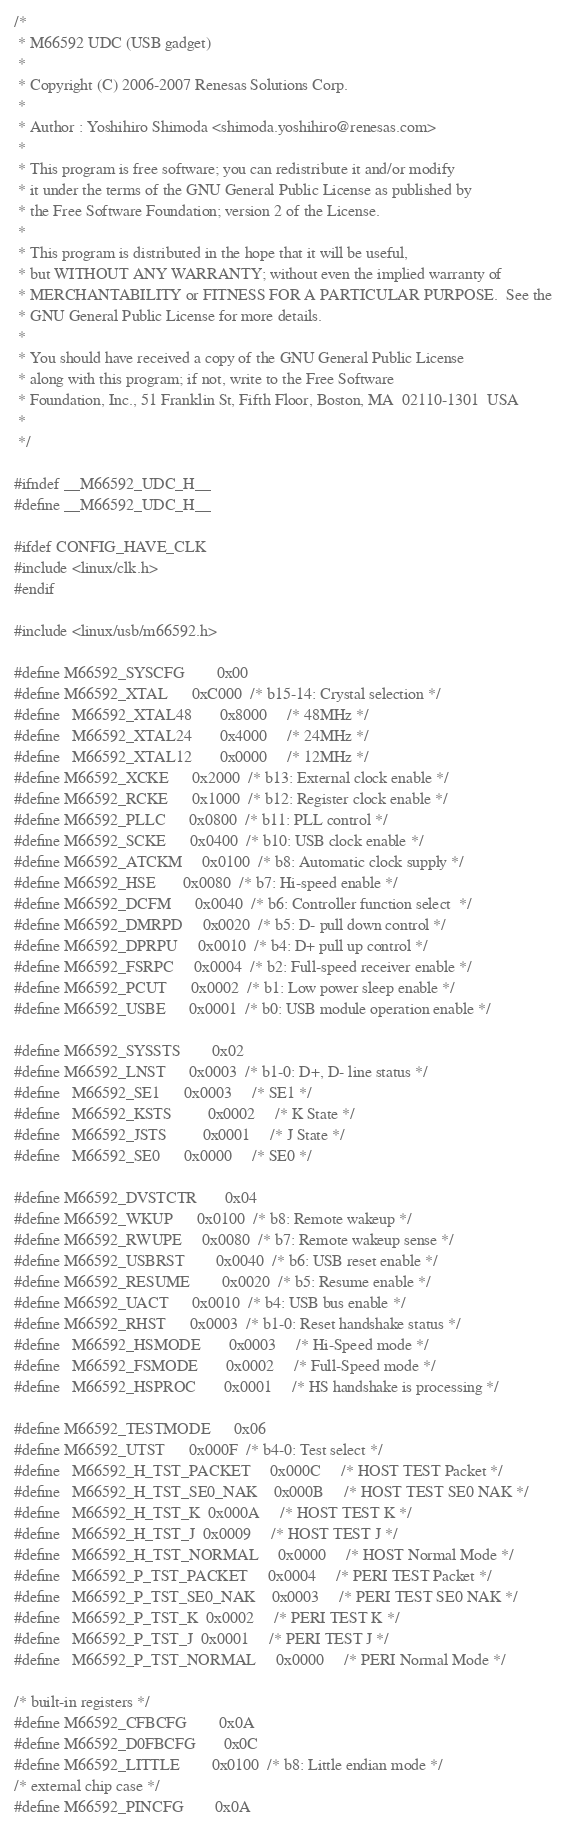Convert code to text. <code><loc_0><loc_0><loc_500><loc_500><_C_>/*
 * M66592 UDC (USB gadget)
 *
 * Copyright (C) 2006-2007 Renesas Solutions Corp.
 *
 * Author : Yoshihiro Shimoda <shimoda.yoshihiro@renesas.com>
 *
 * This program is free software; you can redistribute it and/or modify
 * it under the terms of the GNU General Public License as published by
 * the Free Software Foundation; version 2 of the License.
 *
 * This program is distributed in the hope that it will be useful,
 * but WITHOUT ANY WARRANTY; without even the implied warranty of
 * MERCHANTABILITY or FITNESS FOR A PARTICULAR PURPOSE.  See the
 * GNU General Public License for more details.
 *
 * You should have received a copy of the GNU General Public License
 * along with this program; if not, write to the Free Software
 * Foundation, Inc., 51 Franklin St, Fifth Floor, Boston, MA  02110-1301  USA
 *
 */

#ifndef __M66592_UDC_H__
#define __M66592_UDC_H__

#ifdef CONFIG_HAVE_CLK
#include <linux/clk.h>
#endif

#include <linux/usb/m66592.h>

#define M66592_SYSCFG		0x00
#define M66592_XTAL		0xC000	/* b15-14: Crystal selection */
#define   M66592_XTAL48		 0x8000		/* 48MHz */
#define   M66592_XTAL24		 0x4000		/* 24MHz */
#define   M66592_XTAL12		 0x0000		/* 12MHz */
#define M66592_XCKE		0x2000	/* b13: External clock enable */
#define M66592_RCKE		0x1000	/* b12: Register clock enable */
#define M66592_PLLC		0x0800	/* b11: PLL control */
#define M66592_SCKE		0x0400	/* b10: USB clock enable */
#define M66592_ATCKM		0x0100	/* b8: Automatic clock supply */
#define M66592_HSE		0x0080	/* b7: Hi-speed enable */
#define M66592_DCFM		0x0040	/* b6: Controller function select  */
#define M66592_DMRPD		0x0020	/* b5: D- pull down control */
#define M66592_DPRPU		0x0010	/* b4: D+ pull up control */
#define M66592_FSRPC		0x0004	/* b2: Full-speed receiver enable */
#define M66592_PCUT		0x0002	/* b1: Low power sleep enable */
#define M66592_USBE		0x0001	/* b0: USB module operation enable */

#define M66592_SYSSTS		0x02
#define M66592_LNST		0x0003	/* b1-0: D+, D- line status */
#define   M66592_SE1		 0x0003		/* SE1 */
#define   M66592_KSTS		 0x0002		/* K State */
#define   M66592_JSTS		 0x0001		/* J State */
#define   M66592_SE0		 0x0000		/* SE0 */

#define M66592_DVSTCTR		0x04
#define M66592_WKUP		0x0100	/* b8: Remote wakeup */
#define M66592_RWUPE		0x0080	/* b7: Remote wakeup sense */
#define M66592_USBRST		0x0040	/* b6: USB reset enable */
#define M66592_RESUME		0x0020	/* b5: Resume enable */
#define M66592_UACT		0x0010	/* b4: USB bus enable */
#define M66592_RHST		0x0003	/* b1-0: Reset handshake status */
#define   M66592_HSMODE		 0x0003		/* Hi-Speed mode */
#define   M66592_FSMODE		 0x0002		/* Full-Speed mode */
#define   M66592_HSPROC		 0x0001		/* HS handshake is processing */

#define M66592_TESTMODE		0x06
#define M66592_UTST		0x000F	/* b4-0: Test select */
#define   M66592_H_TST_PACKET	 0x000C		/* HOST TEST Packet */
#define   M66592_H_TST_SE0_NAK	 0x000B		/* HOST TEST SE0 NAK */
#define   M66592_H_TST_K	 0x000A		/* HOST TEST K */
#define   M66592_H_TST_J	 0x0009		/* HOST TEST J */
#define   M66592_H_TST_NORMAL	 0x0000		/* HOST Normal Mode */
#define   M66592_P_TST_PACKET	 0x0004		/* PERI TEST Packet */
#define   M66592_P_TST_SE0_NAK	 0x0003		/* PERI TEST SE0 NAK */
#define   M66592_P_TST_K	 0x0002		/* PERI TEST K */
#define   M66592_P_TST_J	 0x0001		/* PERI TEST J */
#define   M66592_P_TST_NORMAL	 0x0000		/* PERI Normal Mode */

/* built-in registers */
#define M66592_CFBCFG		0x0A
#define M66592_D0FBCFG		0x0C
#define M66592_LITTLE		0x0100	/* b8: Little endian mode */
/* external chip case */
#define M66592_PINCFG		0x0A</code> 